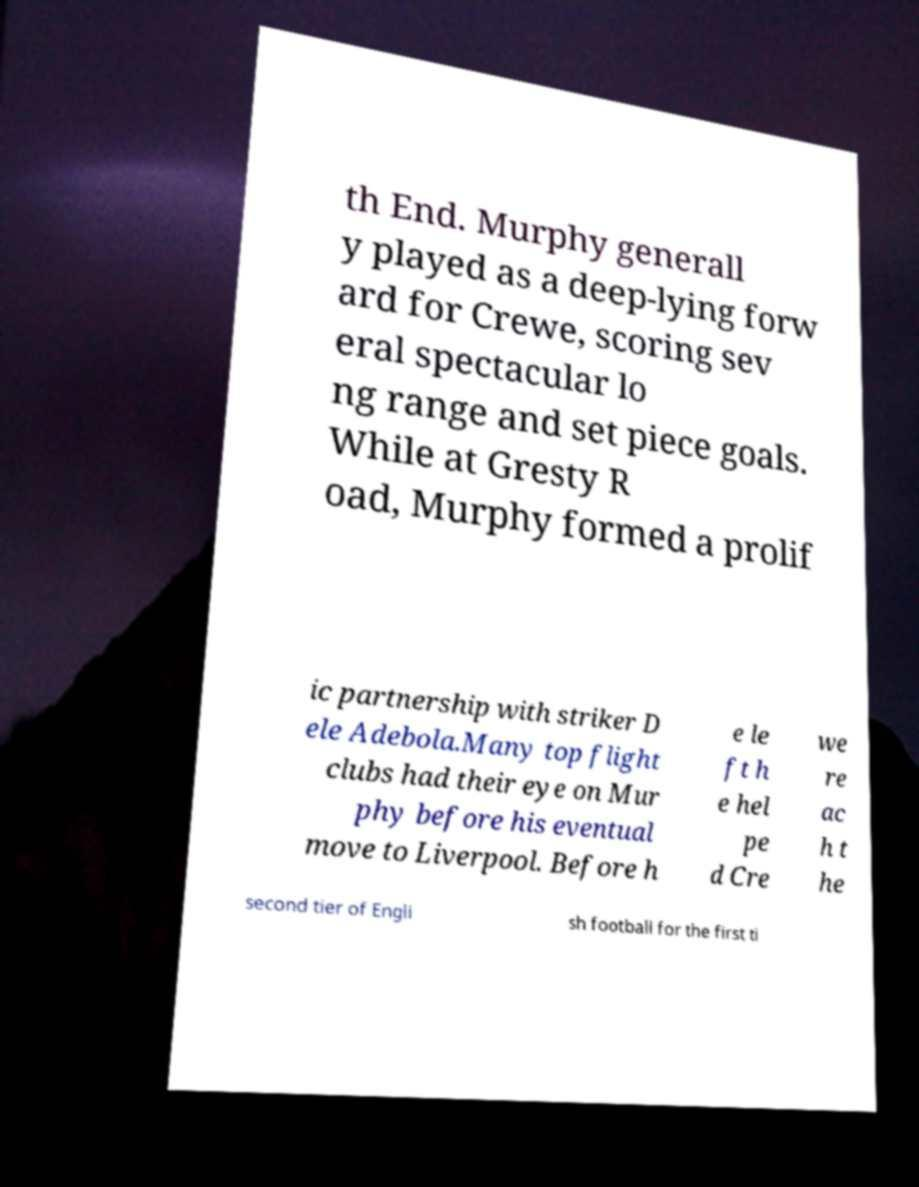Can you accurately transcribe the text from the provided image for me? th End. Murphy generall y played as a deep-lying forw ard for Crewe, scoring sev eral spectacular lo ng range and set piece goals. While at Gresty R oad, Murphy formed a prolif ic partnership with striker D ele Adebola.Many top flight clubs had their eye on Mur phy before his eventual move to Liverpool. Before h e le ft h e hel pe d Cre we re ac h t he second tier of Engli sh football for the first ti 